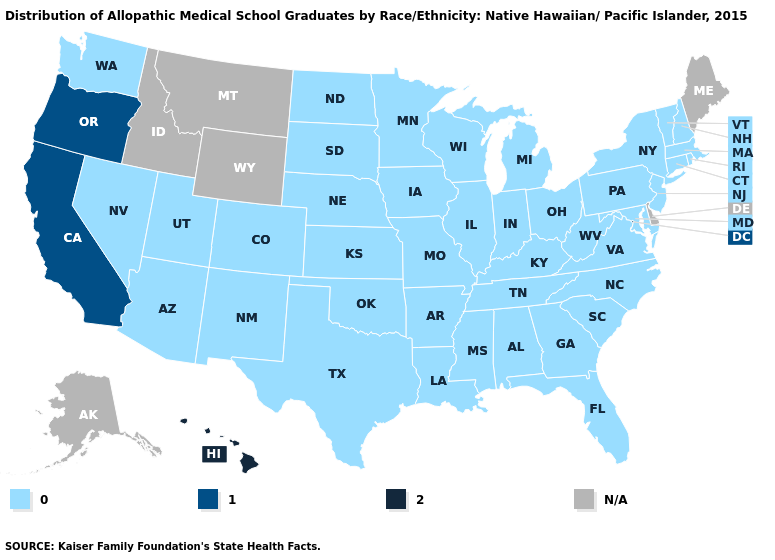What is the value of Illinois?
Be succinct. 0.0. What is the lowest value in the South?
Give a very brief answer. 0.0. How many symbols are there in the legend?
Concise answer only. 4. Name the states that have a value in the range 1.0?
Keep it brief. California, Oregon. Name the states that have a value in the range 1.0?
Answer briefly. California, Oregon. What is the value of Oregon?
Keep it brief. 1.0. Which states have the lowest value in the South?
Give a very brief answer. Alabama, Arkansas, Florida, Georgia, Kentucky, Louisiana, Maryland, Mississippi, North Carolina, Oklahoma, South Carolina, Tennessee, Texas, Virginia, West Virginia. Name the states that have a value in the range 0.0?
Write a very short answer. Alabama, Arizona, Arkansas, Colorado, Connecticut, Florida, Georgia, Illinois, Indiana, Iowa, Kansas, Kentucky, Louisiana, Maryland, Massachusetts, Michigan, Minnesota, Mississippi, Missouri, Nebraska, Nevada, New Hampshire, New Jersey, New Mexico, New York, North Carolina, North Dakota, Ohio, Oklahoma, Pennsylvania, Rhode Island, South Carolina, South Dakota, Tennessee, Texas, Utah, Vermont, Virginia, Washington, West Virginia, Wisconsin. Name the states that have a value in the range 0.0?
Answer briefly. Alabama, Arizona, Arkansas, Colorado, Connecticut, Florida, Georgia, Illinois, Indiana, Iowa, Kansas, Kentucky, Louisiana, Maryland, Massachusetts, Michigan, Minnesota, Mississippi, Missouri, Nebraska, Nevada, New Hampshire, New Jersey, New Mexico, New York, North Carolina, North Dakota, Ohio, Oklahoma, Pennsylvania, Rhode Island, South Carolina, South Dakota, Tennessee, Texas, Utah, Vermont, Virginia, Washington, West Virginia, Wisconsin. What is the value of North Dakota?
Give a very brief answer. 0.0. What is the value of New Hampshire?
Quick response, please. 0.0. Which states have the highest value in the USA?
Answer briefly. Hawaii. 